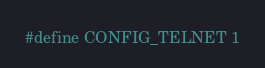<code> <loc_0><loc_0><loc_500><loc_500><_C_>#define CONFIG_TELNET 1
</code> 